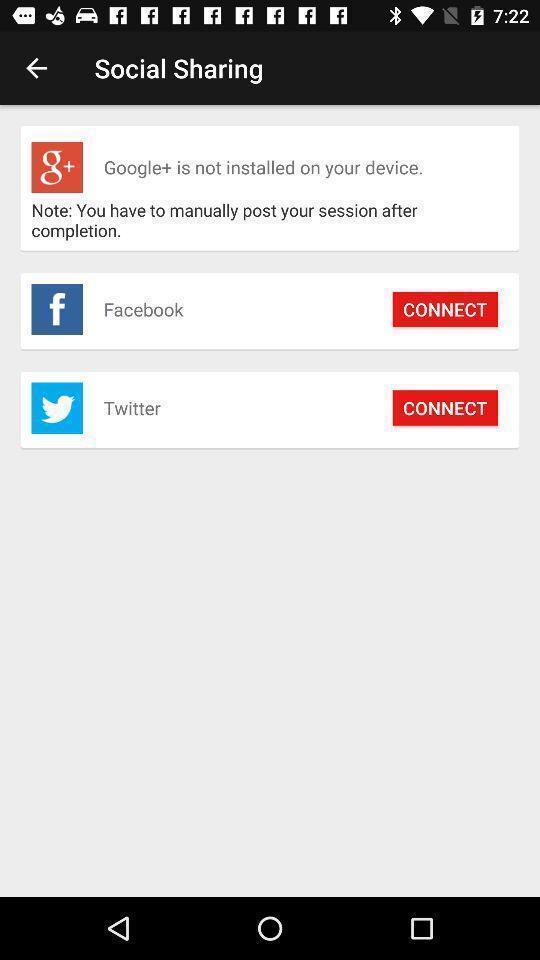Give me a narrative description of this picture. Sharing page displayed through various ways. 